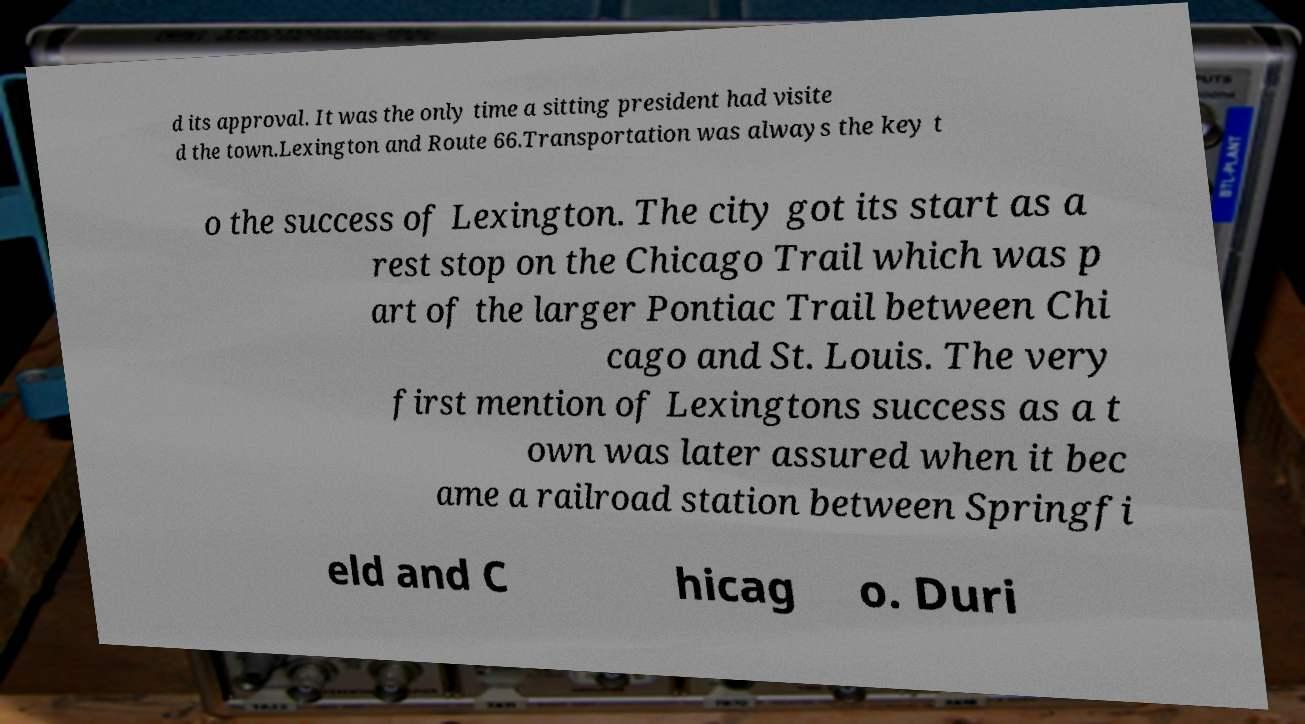Please identify and transcribe the text found in this image. d its approval. It was the only time a sitting president had visite d the town.Lexington and Route 66.Transportation was always the key t o the success of Lexington. The city got its start as a rest stop on the Chicago Trail which was p art of the larger Pontiac Trail between Chi cago and St. Louis. The very first mention of Lexingtons success as a t own was later assured when it bec ame a railroad station between Springfi eld and C hicag o. Duri 